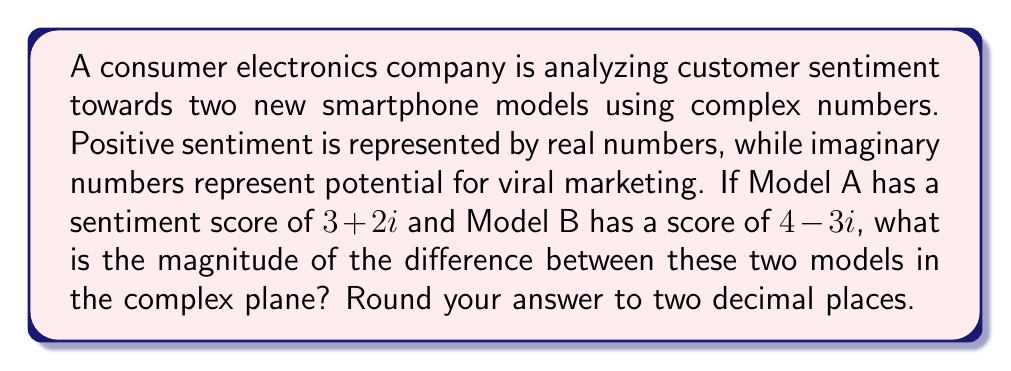Can you solve this math problem? To solve this problem, we'll follow these steps:

1) First, we need to find the difference between the two complex numbers:
   $(4-3i) - (3+2i) = 4-3i-3-2i = 1-5i$

2) Now, we need to calculate the magnitude of this difference. The magnitude of a complex number $a+bi$ is given by the formula:
   $\sqrt{a^2 + b^2}$

3) In our case, $a=1$ and $b=-5$. Let's substitute these into the formula:
   $\sqrt{1^2 + (-5)^2}$

4) Simplify:
   $\sqrt{1 + 25} = \sqrt{26}$

5) Calculate the square root:
   $\sqrt{26} \approx 5.0990$

6) Rounding to two decimal places:
   $5.10$

This magnitude represents the "distance" between the two models in terms of consumer sentiment and viral marketing potential in the complex plane.
Answer: $5.10$ 